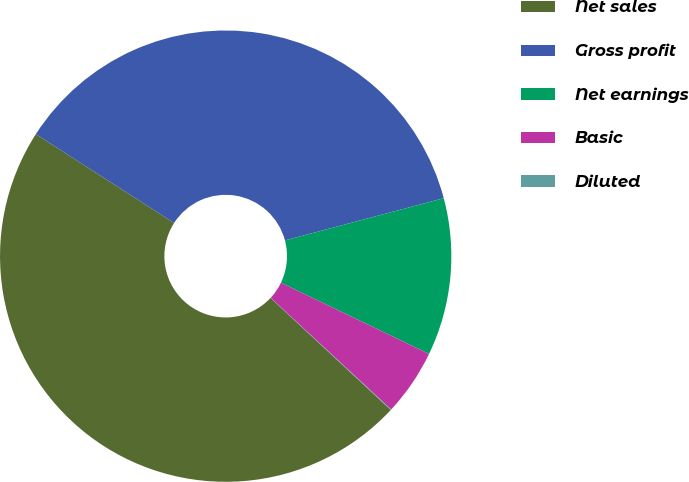Convert chart to OTSL. <chart><loc_0><loc_0><loc_500><loc_500><pie_chart><fcel>Net sales<fcel>Gross profit<fcel>Net earnings<fcel>Basic<fcel>Diluted<nl><fcel>47.16%<fcel>36.78%<fcel>11.27%<fcel>4.76%<fcel>0.04%<nl></chart> 